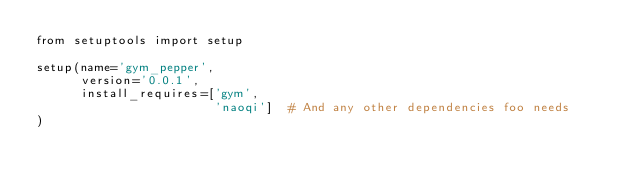<code> <loc_0><loc_0><loc_500><loc_500><_Python_>from setuptools import setup

setup(name='gym_pepper',
      version='0.0.1',
      install_requires=['gym',
                        'naoqi']  # And any other dependencies foo needs
)  
</code> 